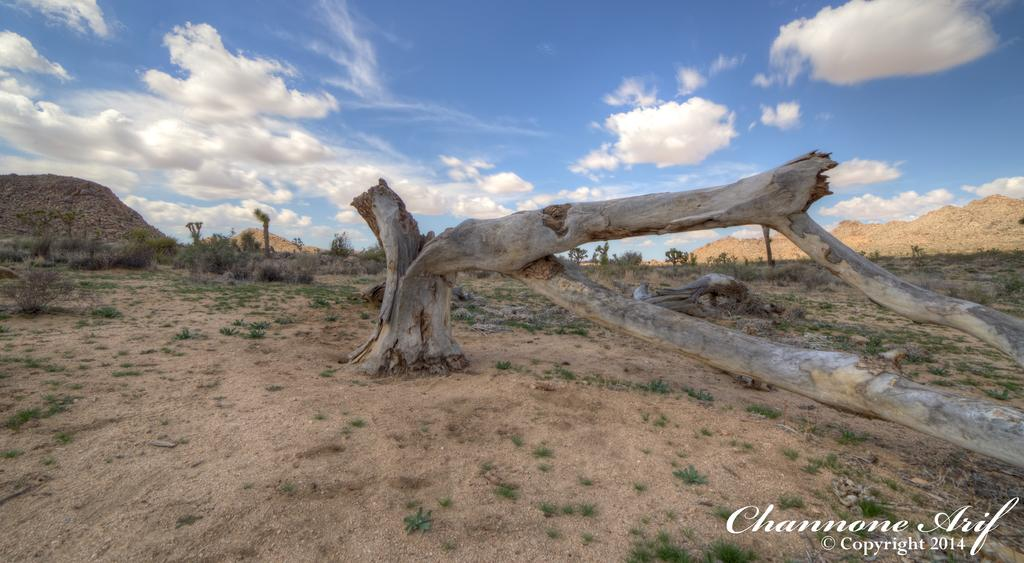What is the main subject in the center of the image? There is a tree trunk in the center of the image. What can be seen in the background of the image? There are plants and mountains visible in the background of the image. How would you describe the sky in the image? The sky is cloudy in the image. What type of plate is being used to serve the comfort food in the image? There is no plate or comfort food present in the image; it features a tree trunk, plants, mountains, and a cloudy sky. 